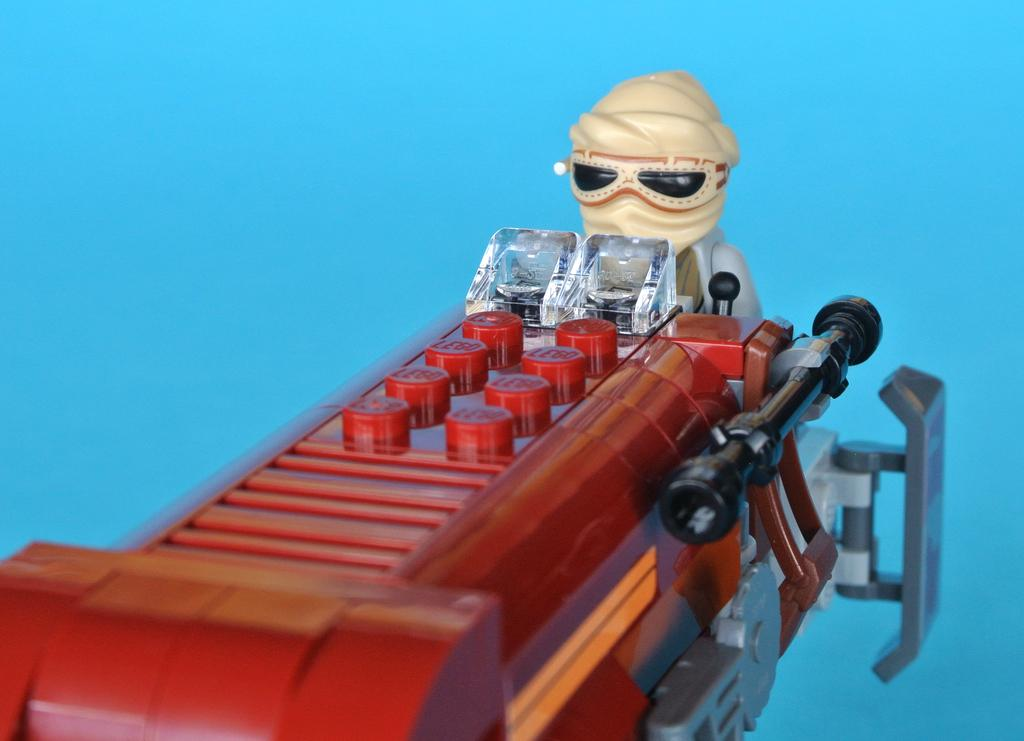What type of toy is in the image? There is a lego toy in the image. Can you describe the lego toy in more detail? There is a lego man in the image. What color is the background of the image? The background of the image is blue. What type of skirt is the lego man wearing in the image? The lego man does not have a skirt, as it is a toy and does not wear clothing. 